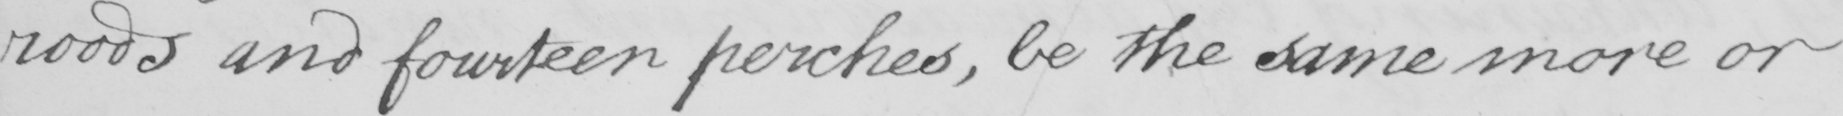What is written in this line of handwriting? roods and fourteen perches , be the same more or 